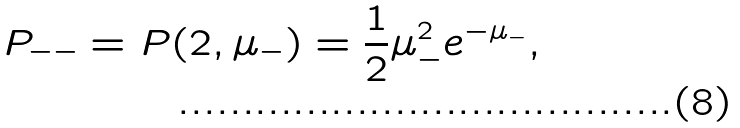Convert formula to latex. <formula><loc_0><loc_0><loc_500><loc_500>P _ { - - } = P ( 2 , \mu _ { - } ) = \frac { 1 } { 2 } \mu _ { - } ^ { 2 } e ^ { - \mu _ { - } } ,</formula> 